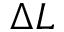Convert formula to latex. <formula><loc_0><loc_0><loc_500><loc_500>\Delta L</formula> 